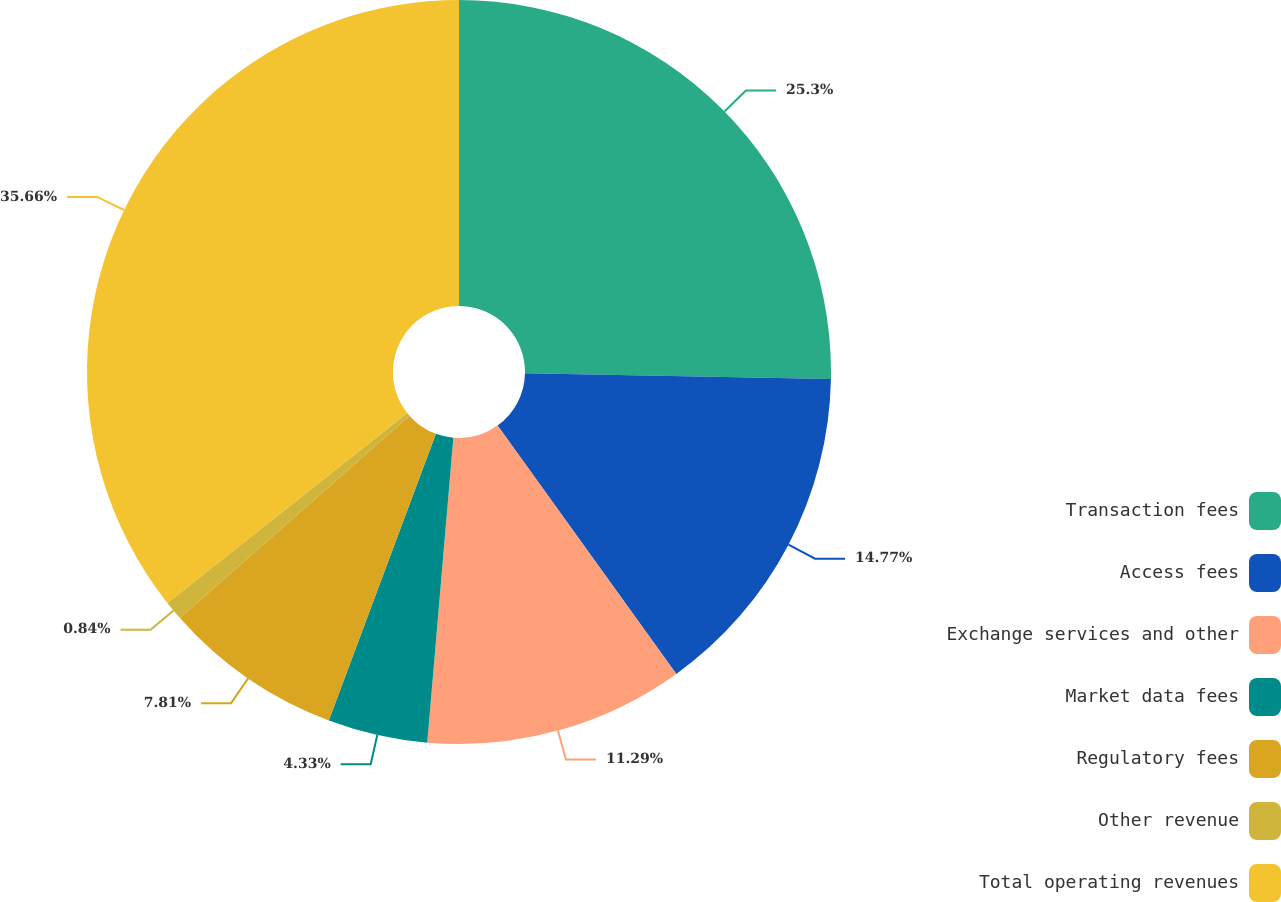<chart> <loc_0><loc_0><loc_500><loc_500><pie_chart><fcel>Transaction fees<fcel>Access fees<fcel>Exchange services and other<fcel>Market data fees<fcel>Regulatory fees<fcel>Other revenue<fcel>Total operating revenues<nl><fcel>25.3%<fcel>14.77%<fcel>11.29%<fcel>4.33%<fcel>7.81%<fcel>0.84%<fcel>35.66%<nl></chart> 